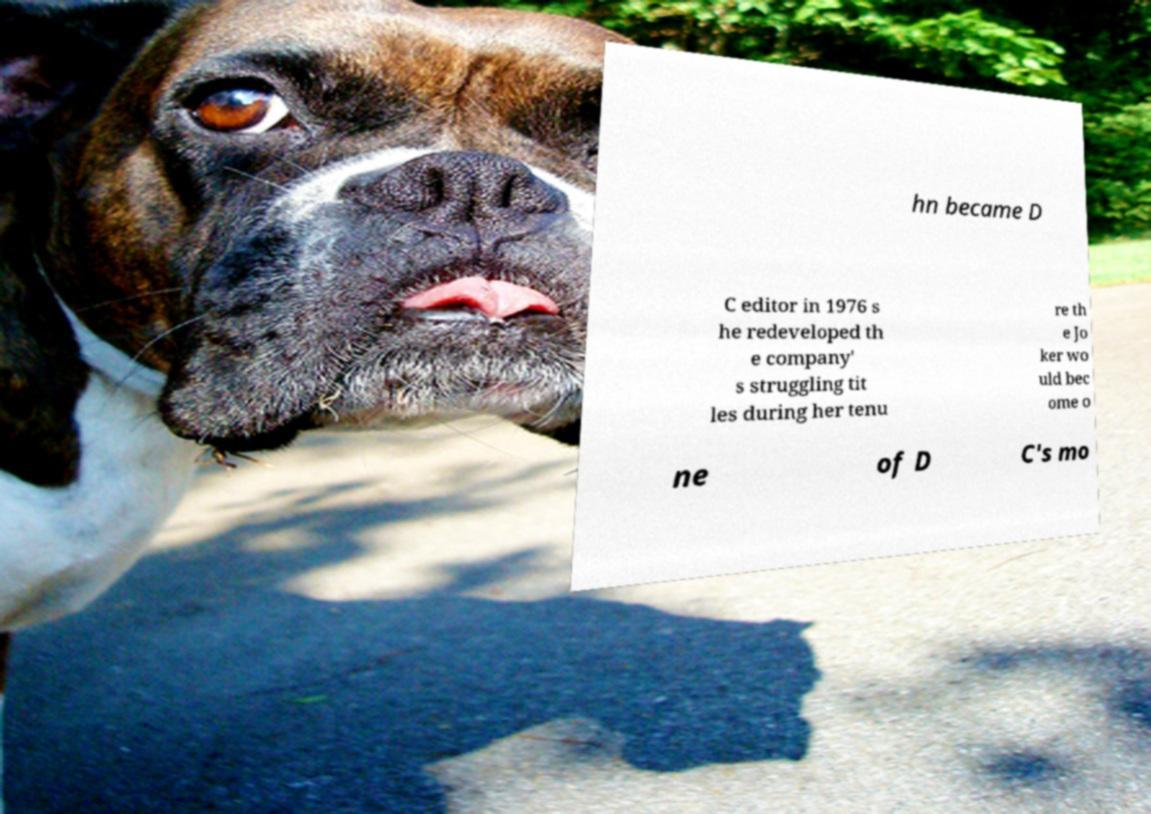Could you assist in decoding the text presented in this image and type it out clearly? hn became D C editor in 1976 s he redeveloped th e company' s struggling tit les during her tenu re th e Jo ker wo uld bec ome o ne of D C's mo 